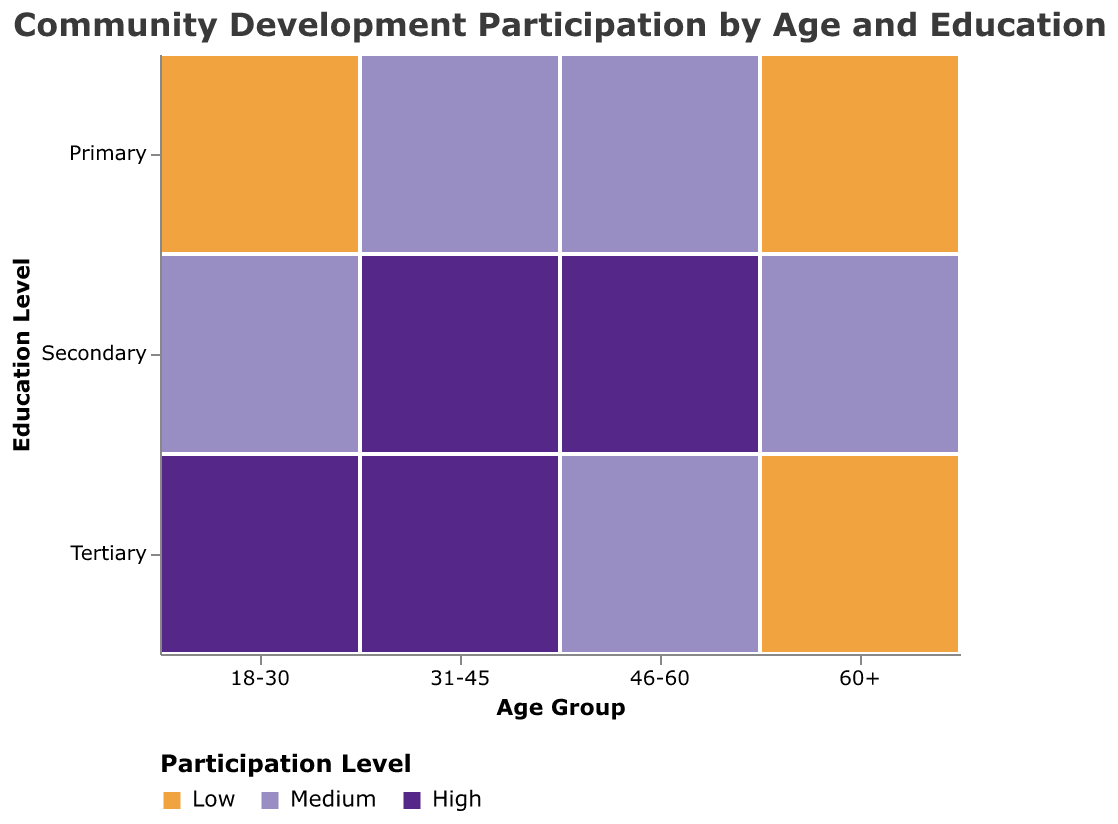What is the title of the plot? The title of the plot is located at the top and it summarizes what the plot is about. Here, the title is "Community Development Participation by Age and Education"
Answer: Community Development Participation by Age and Education How many age groups are displayed in the plot? The age groups are displayed on the x-axis and are represented by different segments. The age groups are "18-30", "31-45", "46-60", and "60+"
Answer: 4 Which age group has the highest participation level for tertiary education? The color representing "High" participation level is used to identify this. For tertiary education, "High" participation is seen for the "31-45" age group
Answer: 31-45 What is the participation level for the 60+ age group with secondary education? The color corresponding to the "60+" age group with secondary education shows a medium participation level.
Answer: Medium Which group has low participation with primary education? The color representing "Low" participation level for primary education is examined across all age groups. "18-30" and "60+" age groups have low participation.
Answer: 18-30, 60+ What participation levels are present for the 46-60 age group with tertiary education? The participation levels are represented by colors. For the "46-60" age group with tertiary education, the color shows a medium participation level.
Answer: Medium Compare the participation levels of the 18-30 age group across different education levels. By examining the colors used for the "18-30" age group, it is evident that primary education has low participation, secondary education has medium participation, and tertiary education has high participation.
Answer: Low (Primary), Medium (Secondary), High (Tertiary) Which age group consistently shows high participation at the secondary education level? Looking at the colors representing high participation across secondary education, "31-45" and "46-60" age groups consistently show high participation.
Answer: 31-45, 46-60 What is the difference in participation level between primary education for the "31-45" and "60+" age groups? Examining the colors representing the participation levels, we see that primary education for "31-45" is medium, while for "60+" it is low. The difference is one level (medium vs low).
Answer: Medium vs Low 